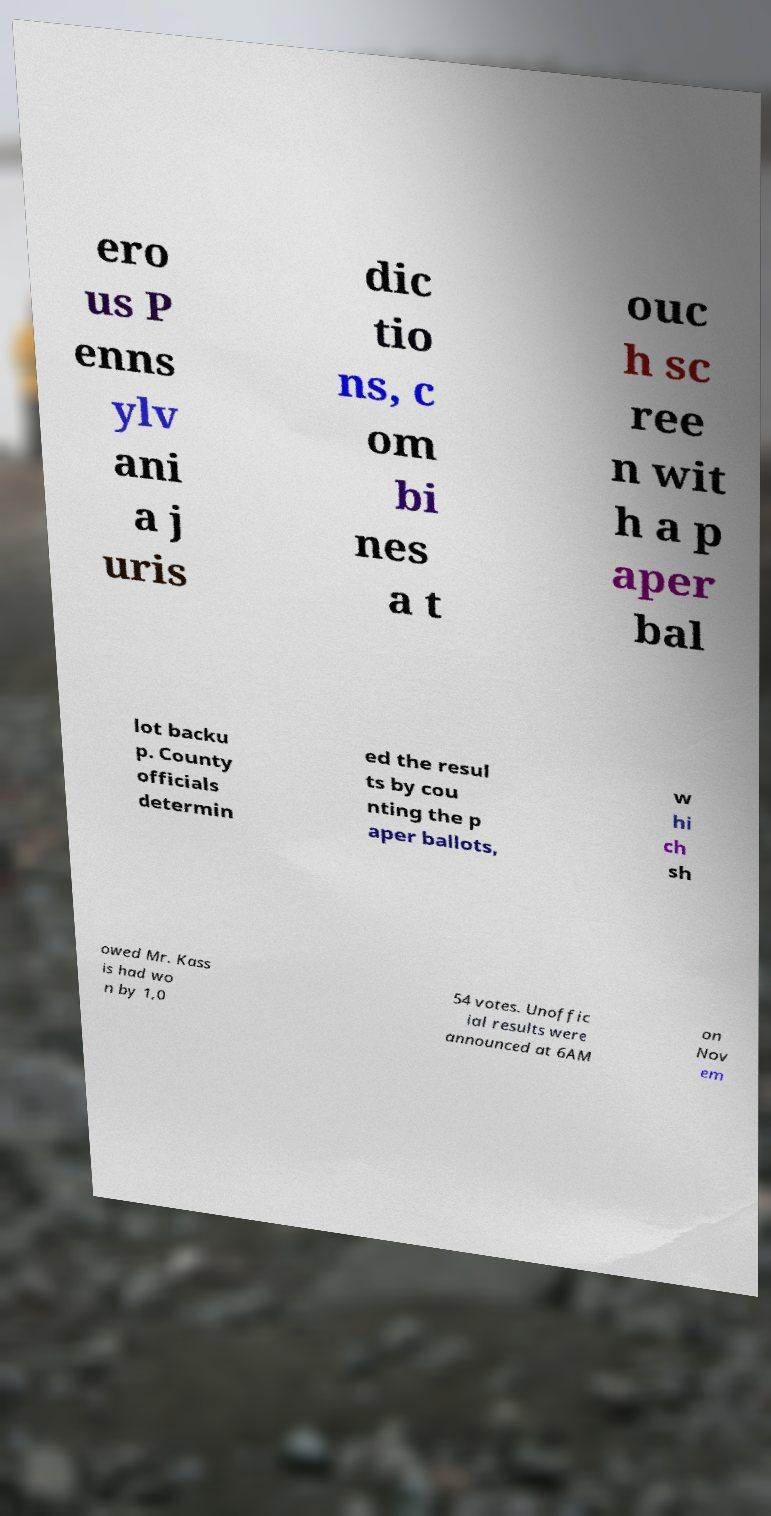There's text embedded in this image that I need extracted. Can you transcribe it verbatim? ero us P enns ylv ani a j uris dic tio ns, c om bi nes a t ouc h sc ree n wit h a p aper bal lot backu p. County officials determin ed the resul ts by cou nting the p aper ballots, w hi ch sh owed Mr. Kass is had wo n by 1,0 54 votes. Unoffic ial results were announced at 6AM on Nov em 